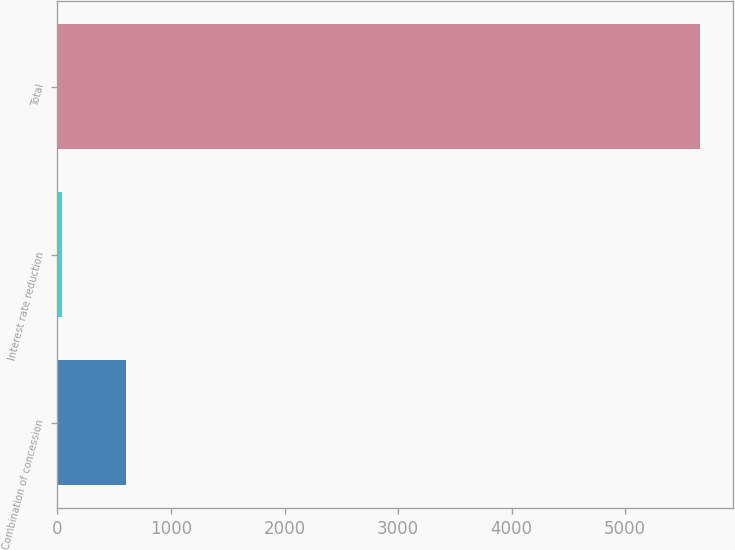Convert chart to OTSL. <chart><loc_0><loc_0><loc_500><loc_500><bar_chart><fcel>Combination of concession<fcel>Interest rate reduction<fcel>Total<nl><fcel>605<fcel>43<fcel>5663<nl></chart> 